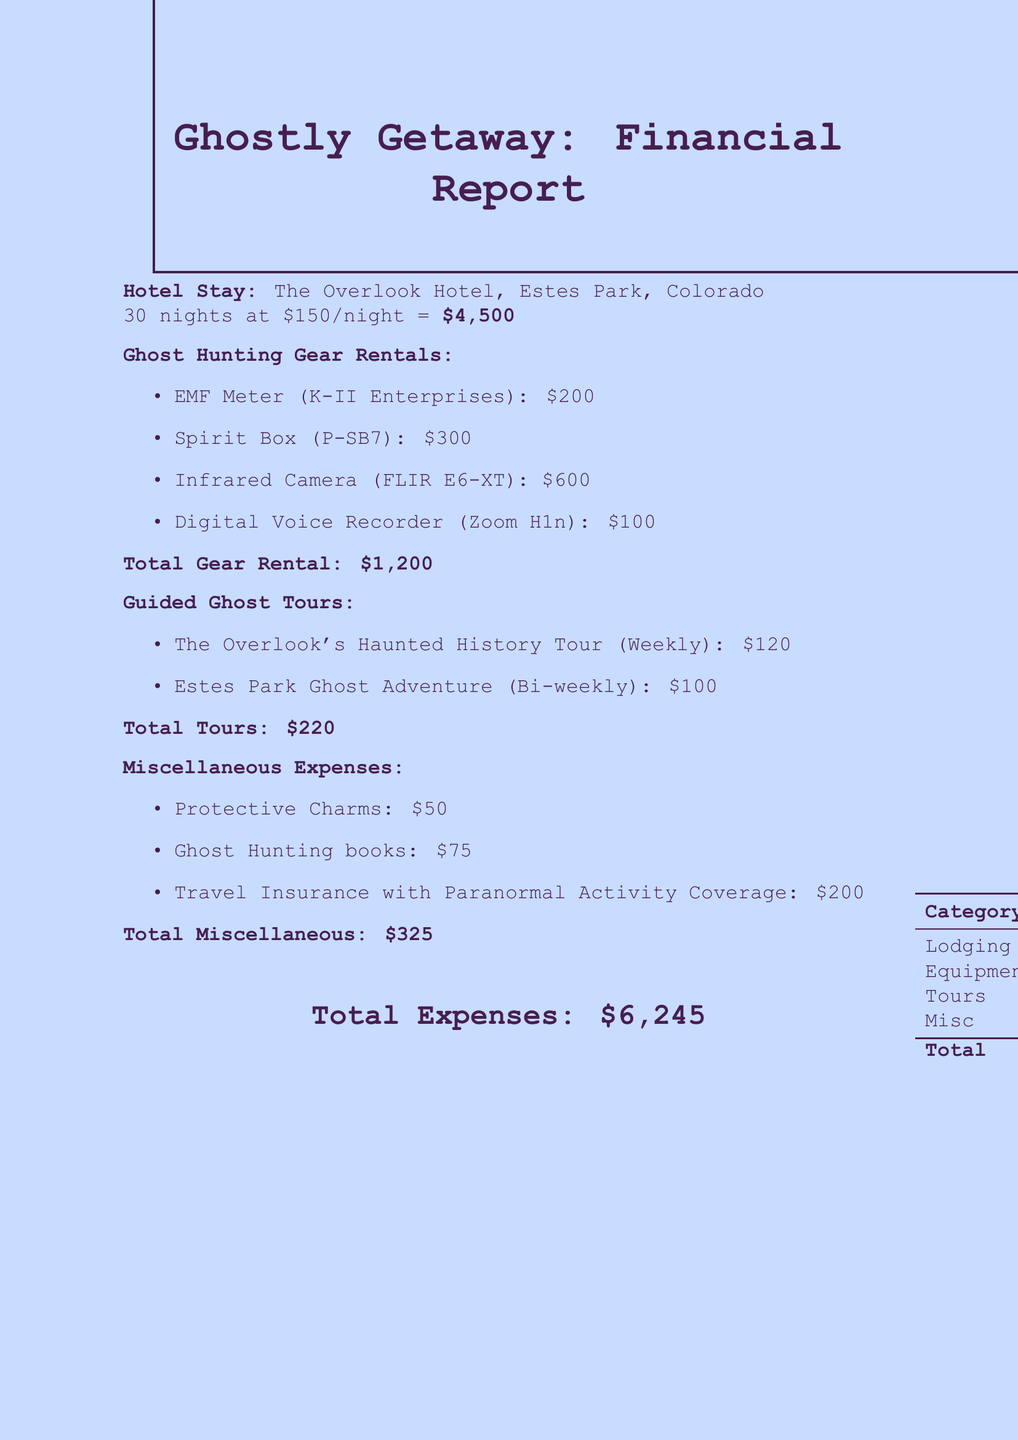What is the name of the hotel? The name of the hotel is provided in the document as part of the hotel stay information.
Answer: The Overlook Hotel What is the nightly rate for the hotel? The document specifies the cost per night for staying in the hotel.
Answer: 150 What is the total lodging cost for the stay? The total lodging cost is computed based on the nightly rate and duration of the stay.
Answer: 4500 What is the total cost for ghost hunting gear rentals? The total rental cost for all ghost hunting gear is listed in the gear rentals section.
Answer: 1200 How many nights is the stay at the hotel? The duration of the hotel stay is explicitly mentioned in the document.
Answer: 30 nights What is the total cost for guided ghost tours? The document summarizes the total expenses related to guided ghost tours.
Answer: 220 How much did the protective charms cost? The cost of protective charms is specified under miscellaneous expenses.
Answer: 50 What is the total amount spent on miscellaneous expenses? The document lists the total for all miscellaneous expenses incurred during the stay.
Answer: 325 What is the overall total of expenses for the month? The complete total expenses sum all individual costs stated throughout the document.
Answer: 6245 